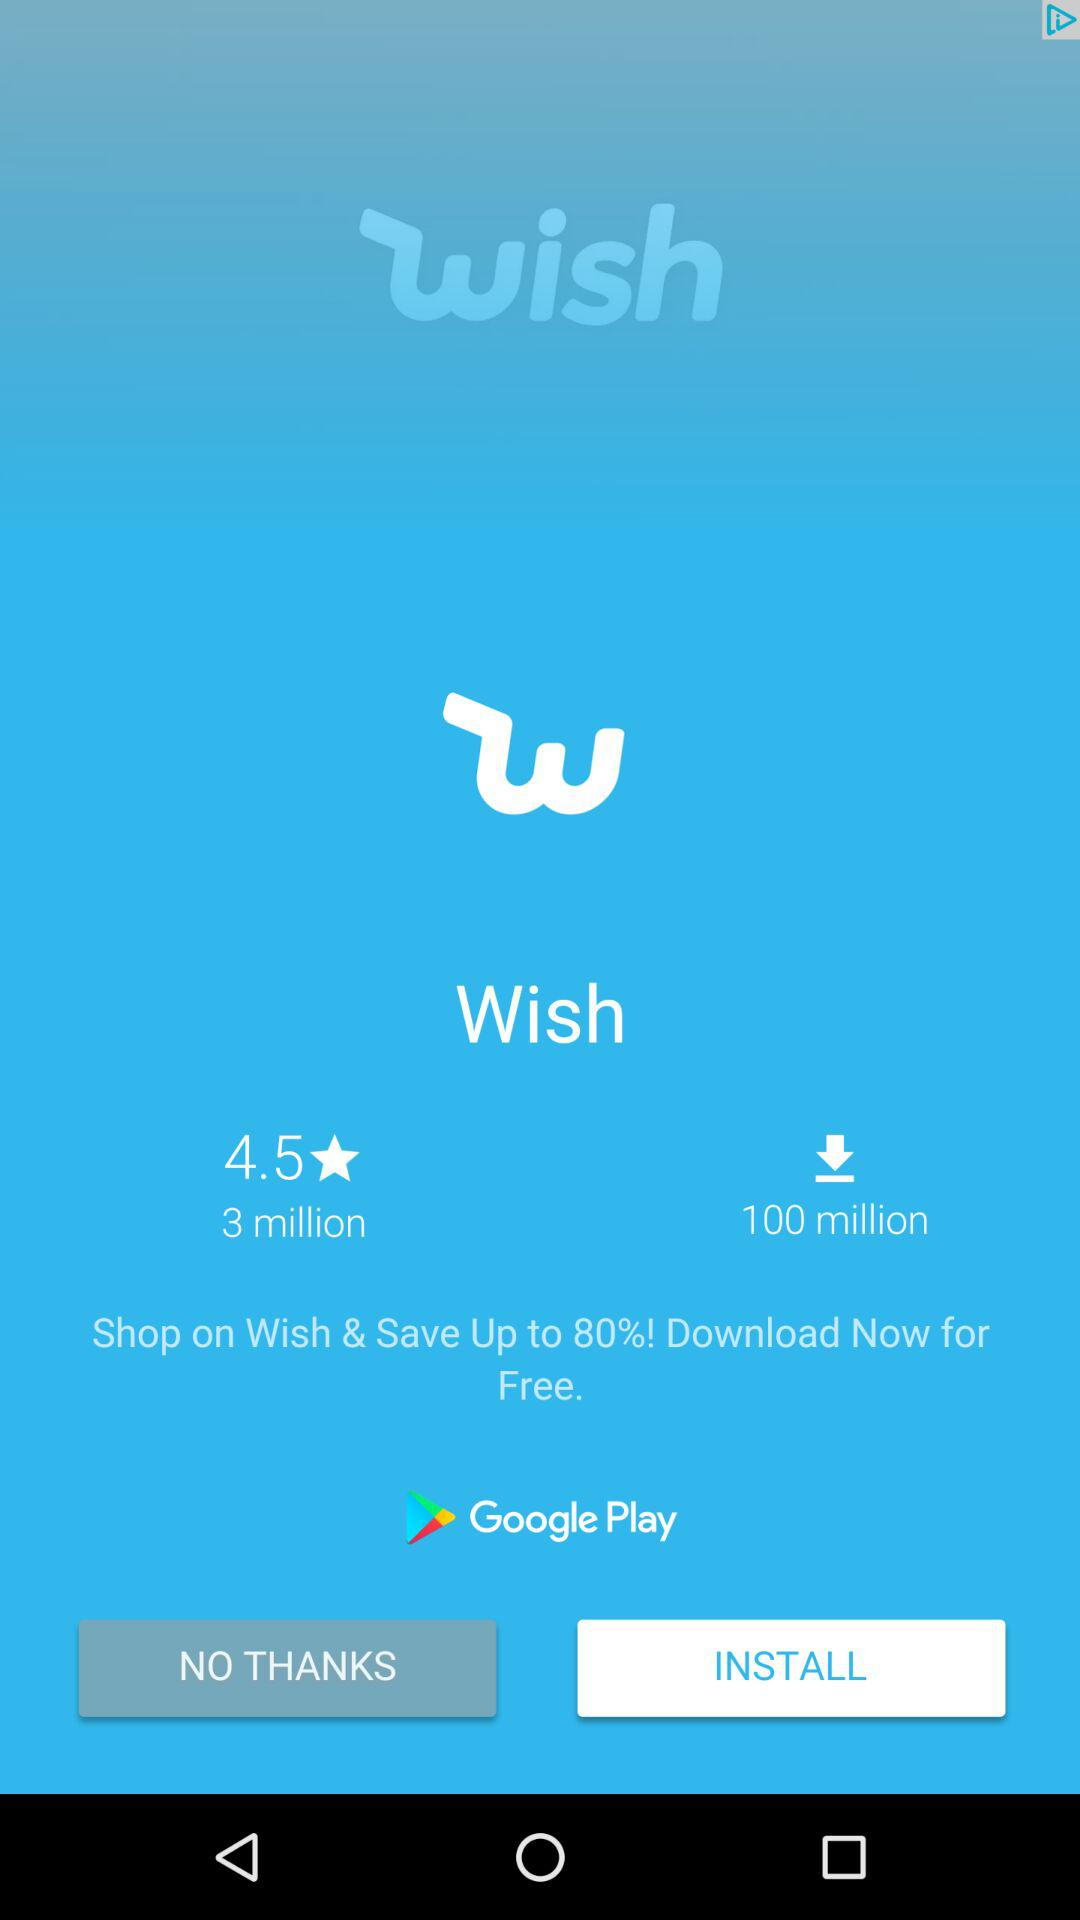How many more users have downloaded Wish than rated it?
Answer the question using a single word or phrase. 97 million 